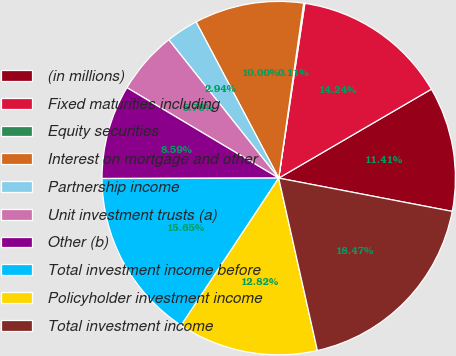Convert chart. <chart><loc_0><loc_0><loc_500><loc_500><pie_chart><fcel>(in millions)<fcel>Fixed maturities including<fcel>Equity securities<fcel>Interest on mortgage and other<fcel>Partnership income<fcel>Unit investment trusts (a)<fcel>Other (b)<fcel>Total investment income before<fcel>Policyholder investment income<fcel>Total investment income<nl><fcel>11.41%<fcel>14.24%<fcel>0.11%<fcel>10.0%<fcel>2.94%<fcel>5.76%<fcel>8.59%<fcel>15.65%<fcel>12.82%<fcel>18.47%<nl></chart> 